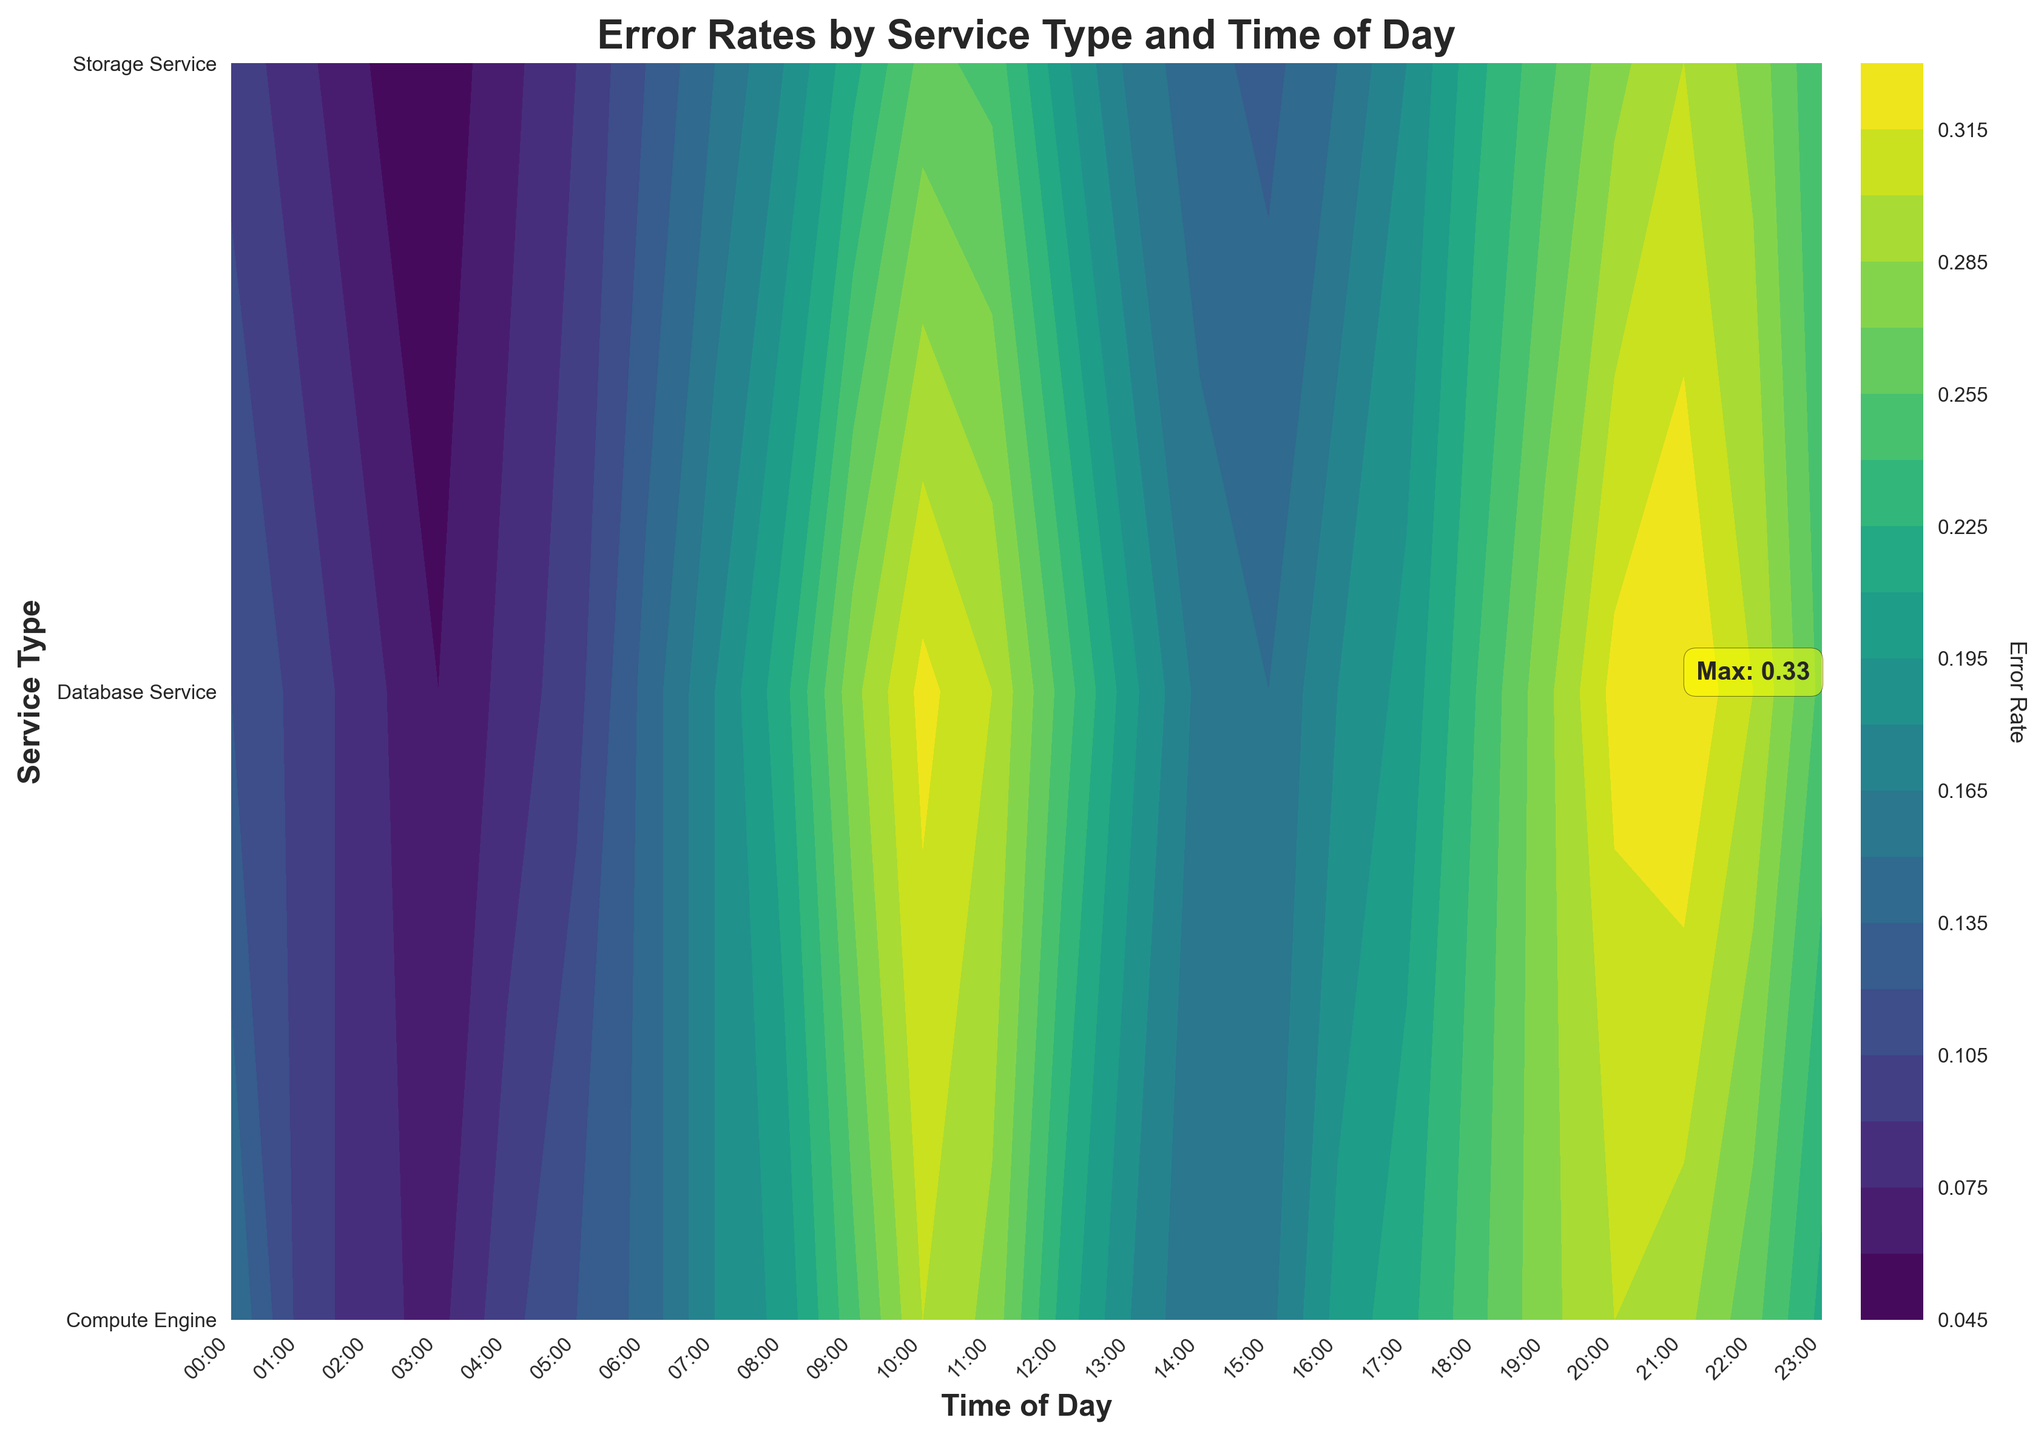How is the plot titled? The title is usually located at the top of the plot and provides a summary of what the plot represents. In this case, the title is clearly visible at the top.
Answer: Error Rates by Service Type and Time of Day What are the axis labels for the plot? Axis labels provide context for the data represented in the plot. These labels are usually found along the x-axis and y-axis. Here, they are clearly labeled at the bottom and the left side of the plot.
Answer: Time of Day (x-axis) and Service Type (y-axis) Which service type has the highest error rate, and at what time of day does it occur? To determine this, look for the annotation on the plot that indicates the maximum error rate, often highlighted with text or a marker. The x-axis position correlates with the time of day, and the y-axis position correlates with the service type. The maximum error rate is annotated on the plot.
Answer: Database Service at 21:00 What is the error rate for Compute Engine at 10:00? Locate the Compute Engine row on the y-axis and follow it horizontally to the 10:00 column on the x-axis, then check the corresponding contour color or annotated number.
Answer: 0.30 During which time of day do all service types show an increasing trend in error rates? Review the gradual changes in contour colors for all service types across different times. Identify a consistent increase in error rates for all services over the time periods.
Answer: 08:00 to 11:00 Compare the error rate trends between Database Service and Storage Service from 00:00 to 23:00. For comparison, follow the contours for both services across all times and observe the differences in gradients. Database Service generally shows higher error rates throughout the day compared to Storage Service.
Answer: Database Service trends higher Which service type shows the lowest error rate, and at what time does this occur? Look for the section of the plot with the darkest color representing the lowest error rate. Identify the service type from the y-axis and the time of day from the x-axis.
Answer: Storage Service at 03:00 What is the average error rate of Compute Engine between 09:00 and 18:00? Identify the error rates of Compute Engine from 09:00 to 18:00, sum these values, then divide by the number of values to get the average. Error rates are: 0.25, 0.30, 0.28, 0.22, 0.18, 0.15, 0.16, 0.20, 0.22, 0.25. Sum is 2.21, and average is 2.21/10.
Answer: 0.221 What trend can you observe in the Storage Service error rates from evening to midnight? Focus on how the contour colors change for the Storage Service from 18:00 to 23:00. These changes indicate how error rates increase or decrease during this time period.
Answer: Increasing trend 